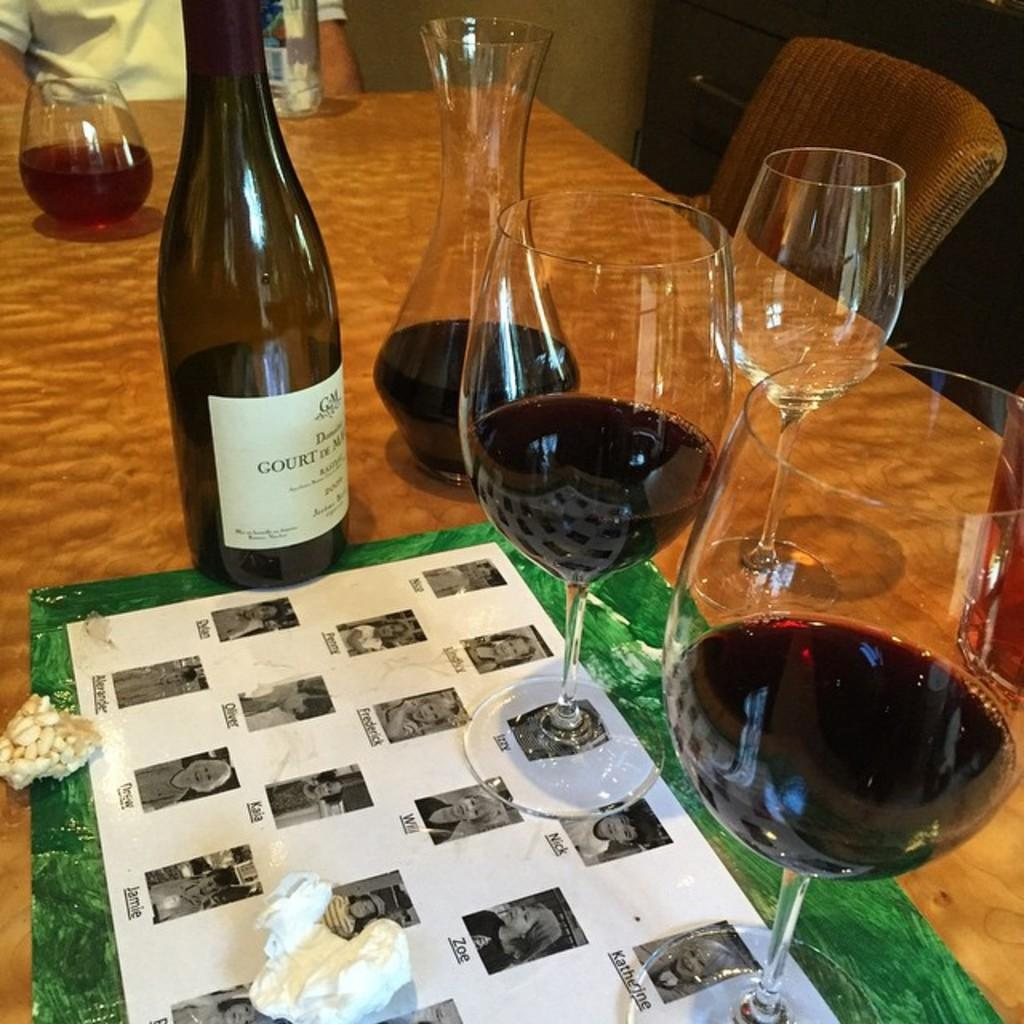What type of beverage containers are on the table in the image? There are wine bottles and glasses on the table. What else can be seen on the table besides the wine bottles and glasses? There is a water bottle on the table. What type of veil is draped over the wine bottles in the image? There is no veil present in the image; the wine bottles are visible without any covering. 